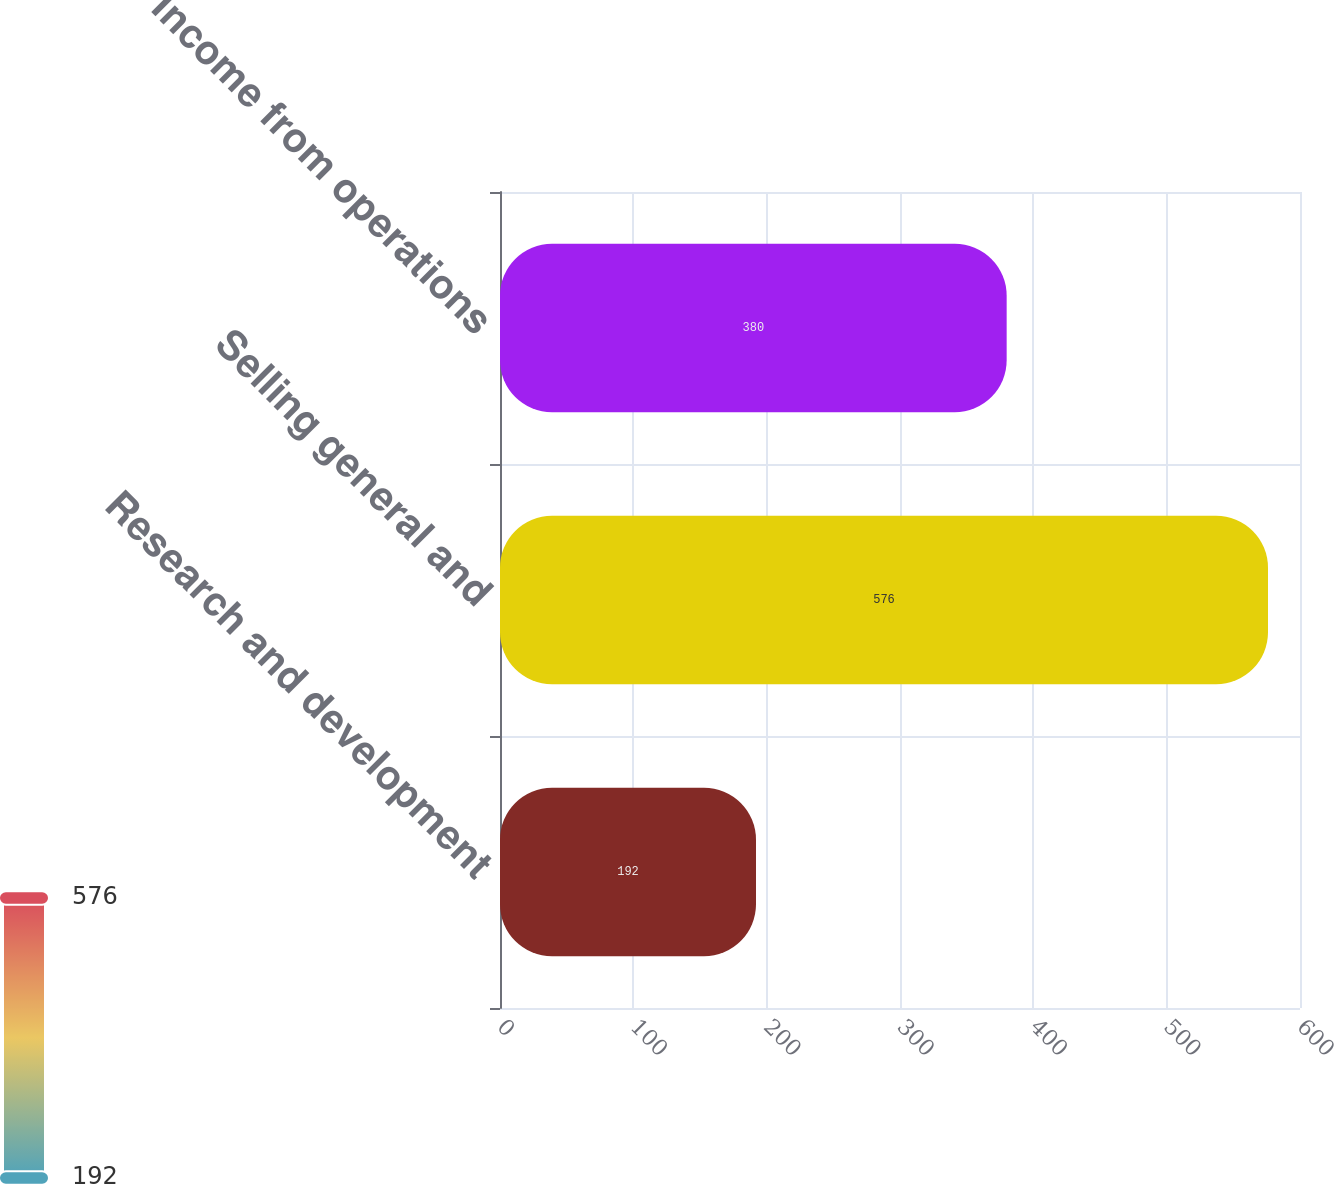Convert chart. <chart><loc_0><loc_0><loc_500><loc_500><bar_chart><fcel>Research and development<fcel>Selling general and<fcel>Income from operations<nl><fcel>192<fcel>576<fcel>380<nl></chart> 